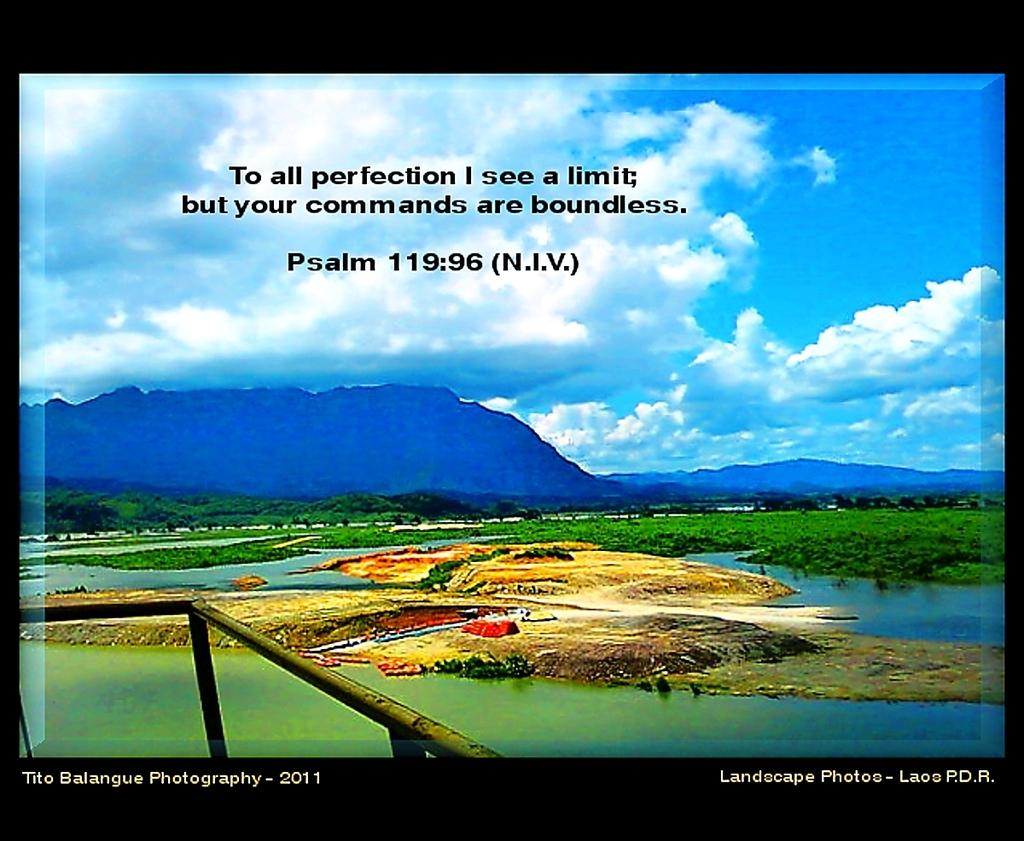What psalm is this?
Your answer should be compact. 119:96. What year was this taken?
Make the answer very short. 2011. 